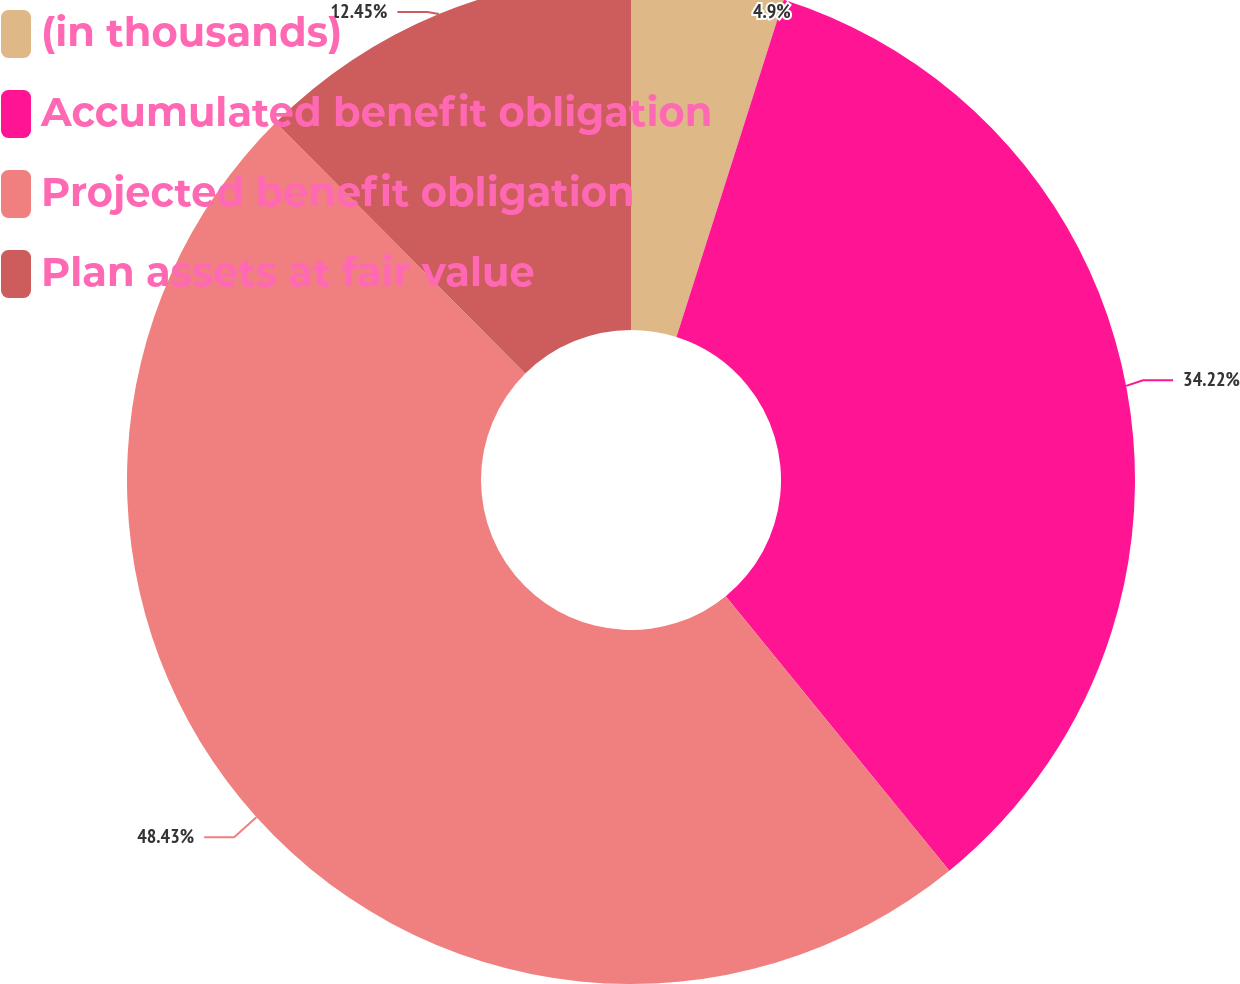Convert chart to OTSL. <chart><loc_0><loc_0><loc_500><loc_500><pie_chart><fcel>(in thousands)<fcel>Accumulated benefit obligation<fcel>Projected benefit obligation<fcel>Plan assets at fair value<nl><fcel>4.9%<fcel>34.22%<fcel>48.43%<fcel>12.45%<nl></chart> 